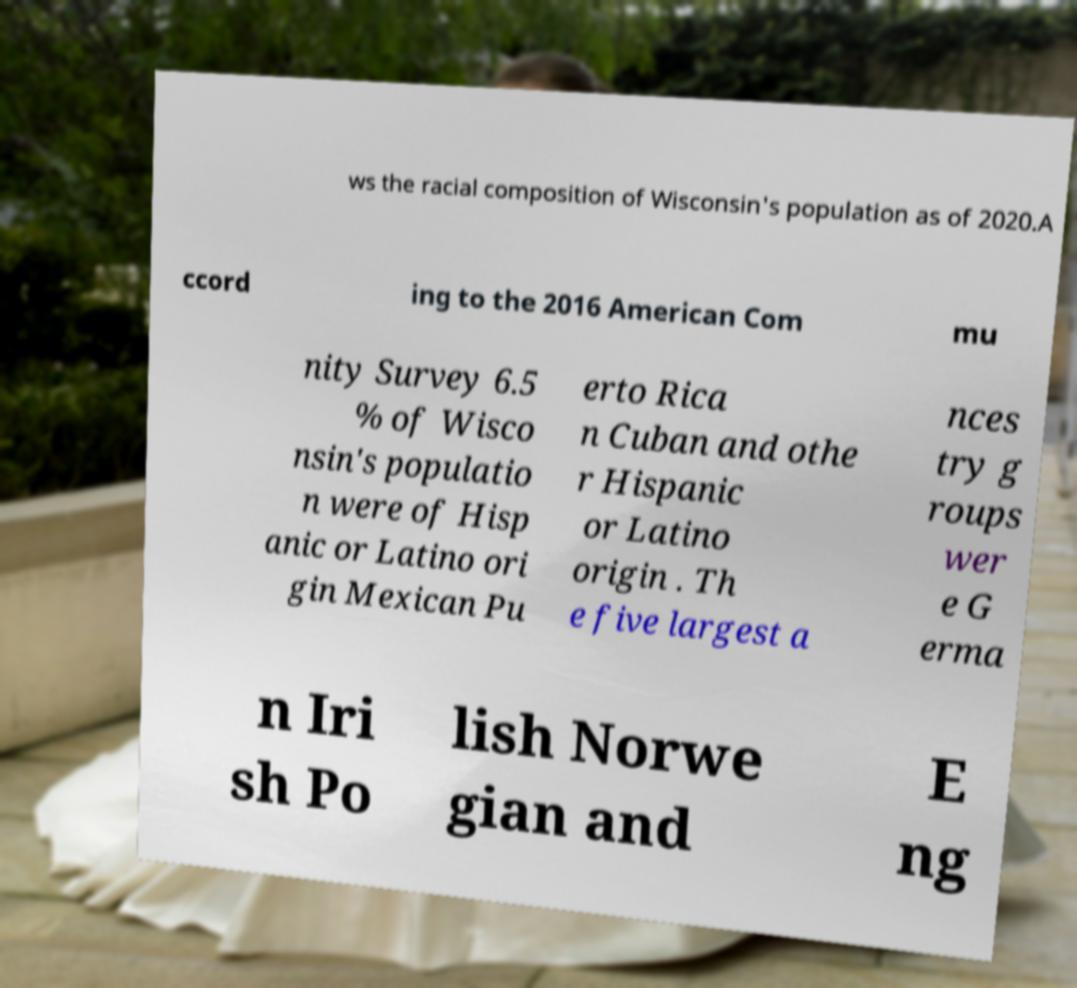There's text embedded in this image that I need extracted. Can you transcribe it verbatim? ws the racial composition of Wisconsin's population as of 2020.A ccord ing to the 2016 American Com mu nity Survey 6.5 % of Wisco nsin's populatio n were of Hisp anic or Latino ori gin Mexican Pu erto Rica n Cuban and othe r Hispanic or Latino origin . Th e five largest a nces try g roups wer e G erma n Iri sh Po lish Norwe gian and E ng 